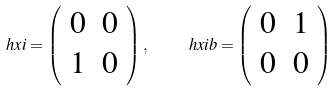Convert formula to latex. <formula><loc_0><loc_0><loc_500><loc_500>\ h x i = \left ( \begin{array} { c c } 0 & 0 \\ 1 & 0 \end{array} \right ) , \quad \ h x i b = \left ( \begin{array} { c c } 0 & 1 \\ 0 & 0 \end{array} \right )</formula> 